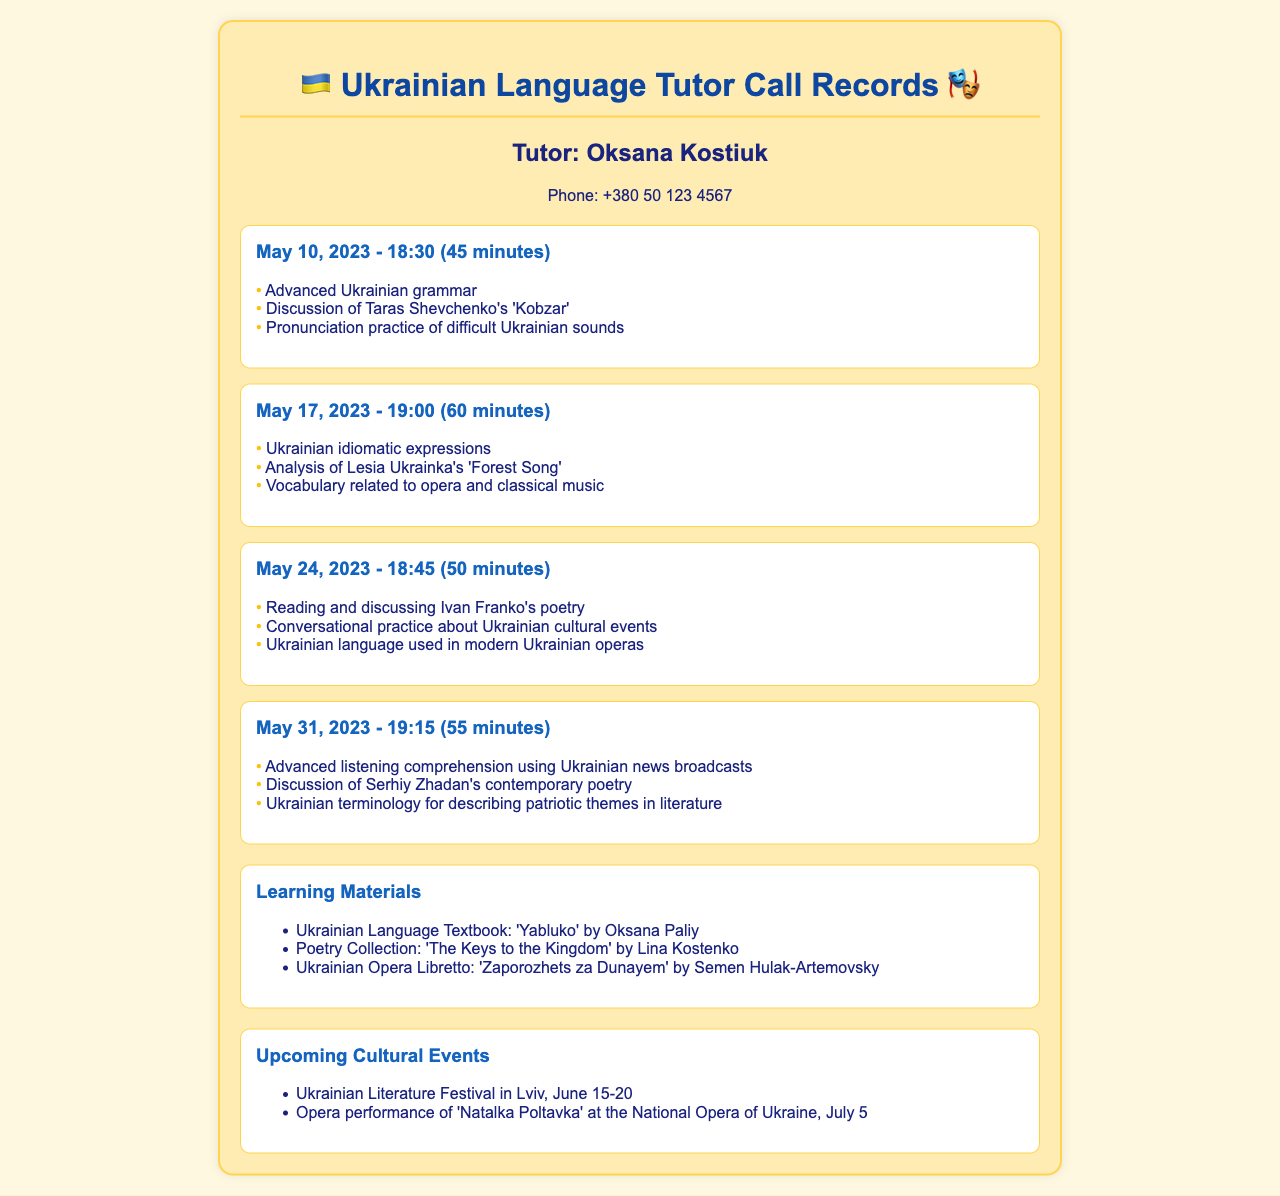What is the name of the tutor? The document provides the name of the tutor in the tutor info section.
Answer: Oksana Kostiuk What is the phone number of the tutor? The phone number can be found in the tutor info section of the document.
Answer: +380 50 123 4567 How long was the call on May 17, 2023? The duration of the call is mentioned in the call record for that date.
Answer: 60 minutes Which work by Taras Shevchenko was discussed? The document lists this work in the topics for the call on May 10, 2023.
Answer: 'Kobzar' What is one of the upcoming cultural events? The document mentions this in the events section.
Answer: Ukrainian Literature Festival in Lviv What type of expressions were discussed on May 17, 2023? The document specifically mentions this topic in the call record for that date.
Answer: Ukrainian idiomatic expressions Which Ukrainian poet's contemporary poetry was discussed last? The document mentions this poet in the May 31, 2023 call record.
Answer: Serhiy Zhadan What language skill was practiced in the last call? This skill is mentioned in the topics of the call on May 31, 2023.
Answer: Advanced listening comprehension How many minutes was the call on May 24, 2023? The duration of the call can be found in the call record for that date.
Answer: 50 minutes 